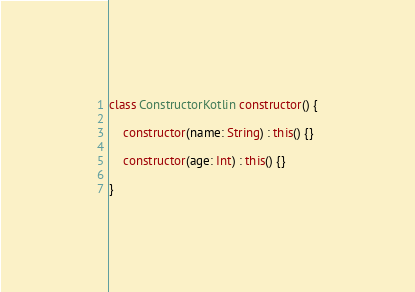Convert code to text. <code><loc_0><loc_0><loc_500><loc_500><_Kotlin_>class ConstructorKotlin constructor() {

    constructor(name: String) : this() {}

    constructor(age: Int) : this() {}

}


</code> 